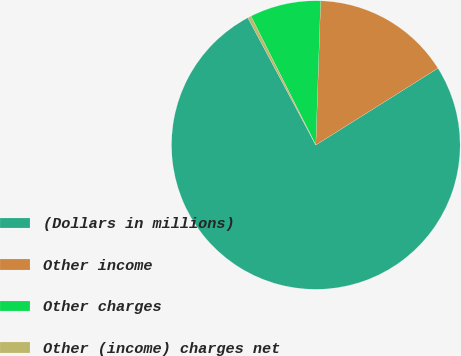Convert chart. <chart><loc_0><loc_0><loc_500><loc_500><pie_chart><fcel>(Dollars in millions)<fcel>Other income<fcel>Other charges<fcel>Other (income) charges net<nl><fcel>76.13%<fcel>15.53%<fcel>7.96%<fcel>0.38%<nl></chart> 